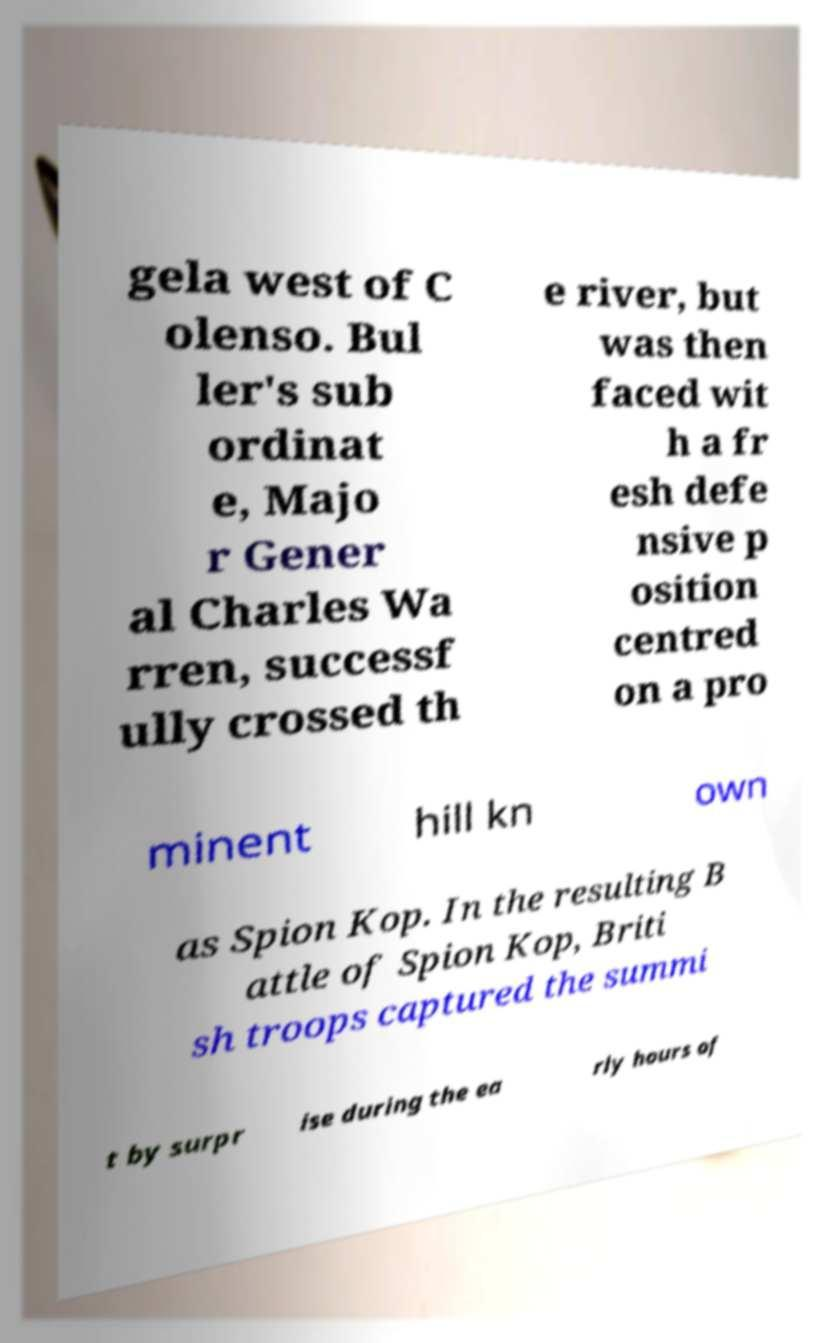There's text embedded in this image that I need extracted. Can you transcribe it verbatim? gela west of C olenso. Bul ler's sub ordinat e, Majo r Gener al Charles Wa rren, successf ully crossed th e river, but was then faced wit h a fr esh defe nsive p osition centred on a pro minent hill kn own as Spion Kop. In the resulting B attle of Spion Kop, Briti sh troops captured the summi t by surpr ise during the ea rly hours of 